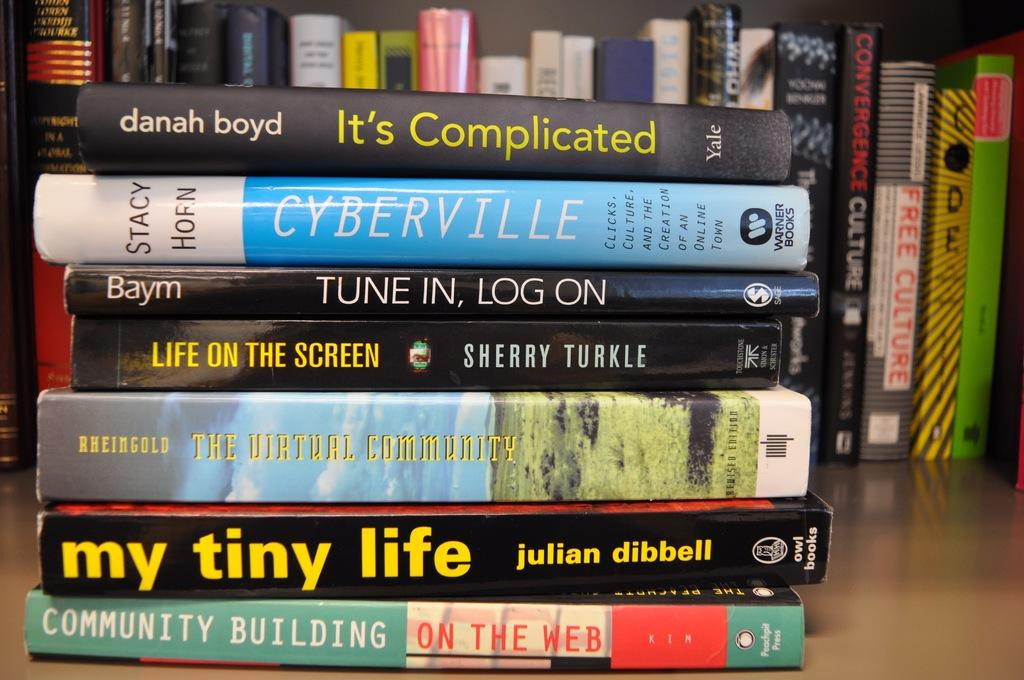<image>
Relay a brief, clear account of the picture shown. A stack of books includes titles such as It's Complicated, Life on the Screen and The Virtual Community. 